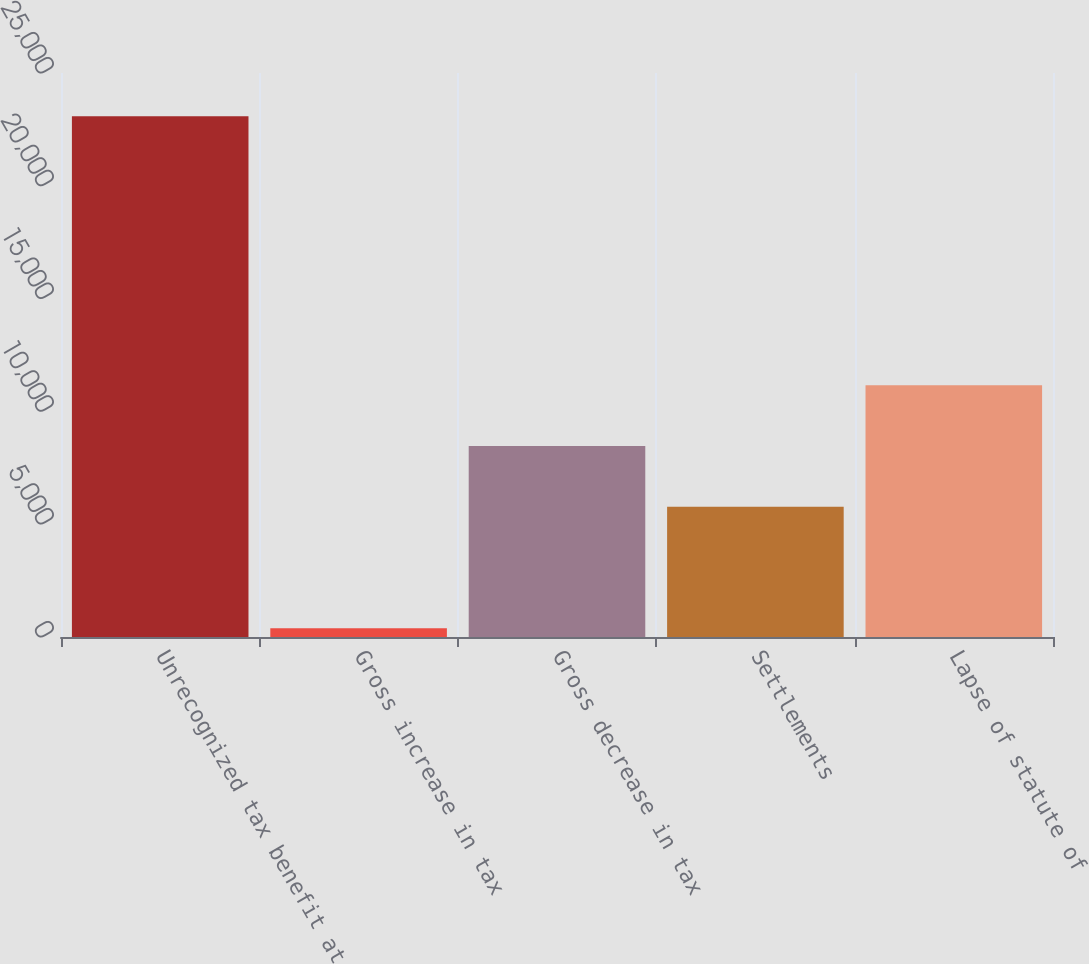<chart> <loc_0><loc_0><loc_500><loc_500><bar_chart><fcel>Unrecognized tax benefit at<fcel>Gross increase in tax<fcel>Gross decrease in tax<fcel>Settlements<fcel>Lapse of statute of<nl><fcel>23080<fcel>392<fcel>8471<fcel>5778<fcel>11164<nl></chart> 